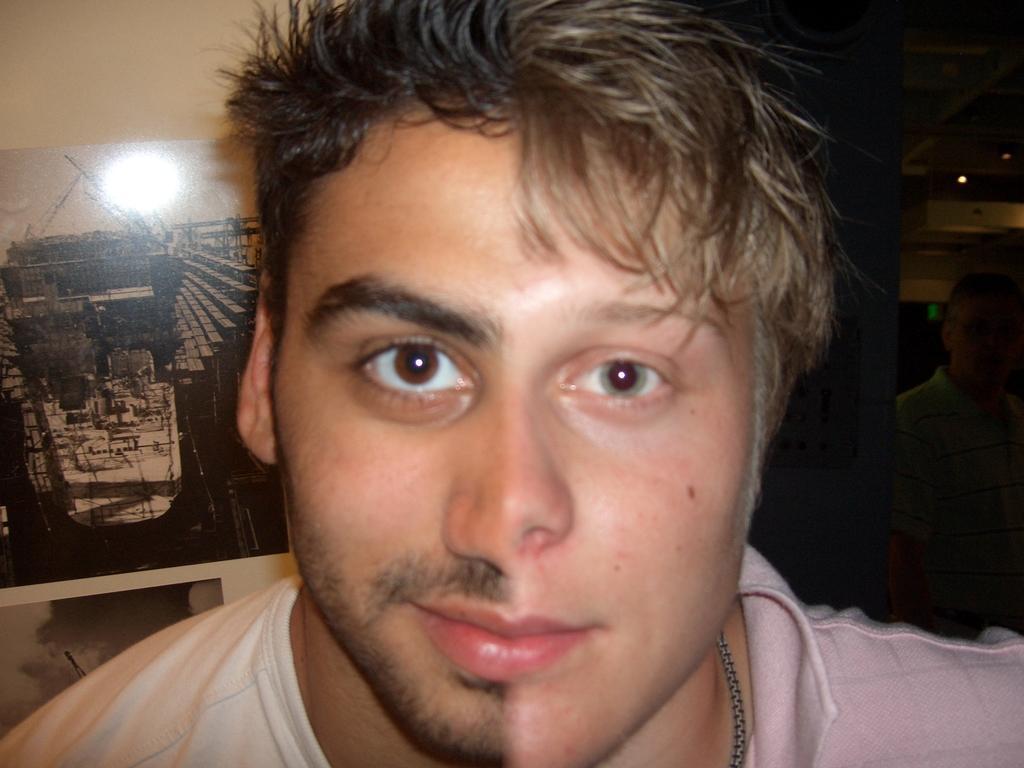Please provide a concise description of this image. This is an edited image. Here I can see two persons faces edited as one face. On the right side there is dark. On the left side there is a photo frame attached to the wall. 